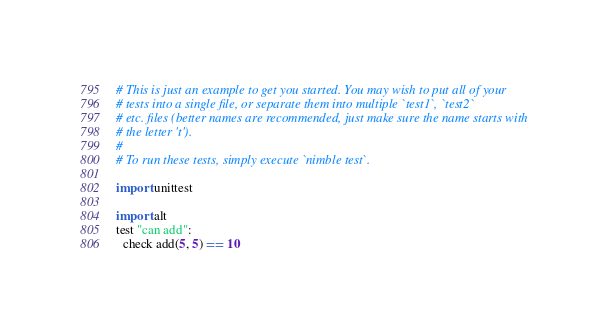Convert code to text. <code><loc_0><loc_0><loc_500><loc_500><_Nim_># This is just an example to get you started. You may wish to put all of your
# tests into a single file, or separate them into multiple `test1`, `test2`
# etc. files (better names are recommended, just make sure the name starts with
# the letter 't').
#
# To run these tests, simply execute `nimble test`.

import unittest

import alt
test "can add":
  check add(5, 5) == 10
</code> 